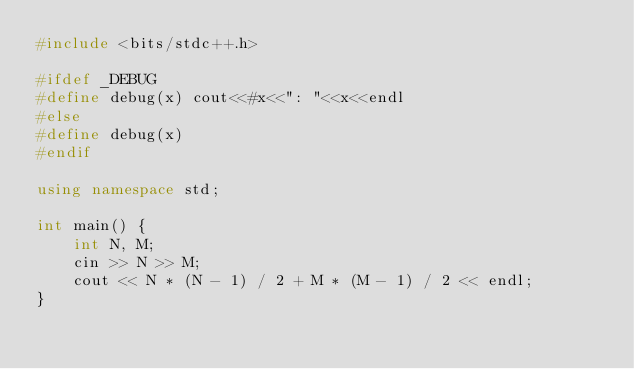<code> <loc_0><loc_0><loc_500><loc_500><_C++_>#include <bits/stdc++.h>

#ifdef _DEBUG
#define debug(x) cout<<#x<<": "<<x<<endl
#else
#define debug(x)
#endif

using namespace std;

int main() {
    int N, M;
    cin >> N >> M;
    cout << N * (N - 1) / 2 + M * (M - 1) / 2 << endl;
}</code> 